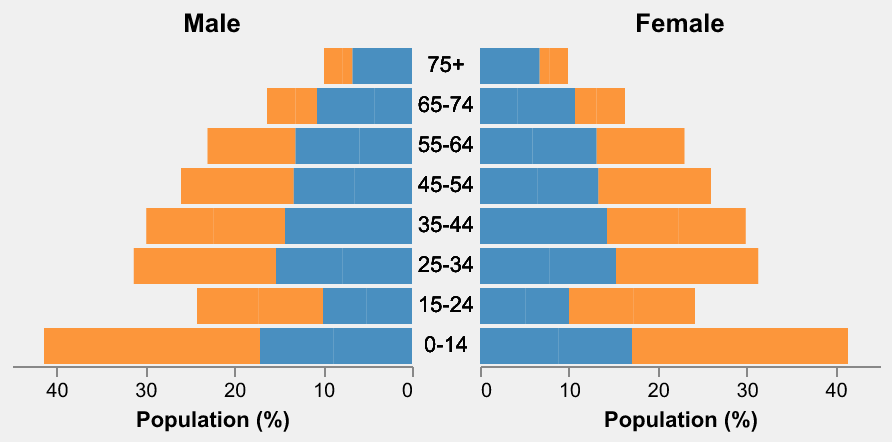What is the age group with the highest male population percentage in Vietnam? To find the age group with the highest male population percentage in Vietnam, look for the largest negative value in the "Vietnam Male" data column. The age group "0-14" has the value -12.5.
Answer: 0-14 Which age group has a larger female population percentage in Russia compared to Vietnam? Compare the percentages of female population for each age group between Russia and Vietnam. In the "55-64" age group, Russia has 7.2% while Vietnam has 5.1%.
Answer: 55-64 What is the total population percentage for the travel-prone age groups (15-64) for both genders in Russia? Sum the male and female population percentages for age groups 15-24, 25-34, 35-44, 45-54, and 55-64 in Russia. The calculation is: (-5.1 + 4.9) + (-7.8 + 7.5) + (-7.2 + 7.1) + (-6.5 + 6.8) + (-5.9 + 7.2) = -5.1 + 4.9 - 7.8 + 7.5 - 7.2 + 7.1 - 6.5 + 6.8 - 5.9 + 7.2 = -32.5% for males and 33.5% for females.
Answer: -32.5% for males, 33.5% for females How does the population percentage of the 25-34 age group in Vietnam compare between genders? Compare the negative value for males and positive value for females in the "25-34" age group in Vietnam. Males have -8.2% and females have 7.8%.
Answer: Males: -8.2%, Females: 7.8% In which age group do both countries have nearly equal male population percentages? Look for the age group where the male percentage values in Vietnam and Russia are close. In the "45-54" age group, both Vietnam and Russia have -6.5%.
Answer: 45-54 What is the average female population percentage for the age groups 35-44 and 45-54 in Vietnam? Add the female population percentages for age groups 35-44 and 45-54 in Vietnam, then divide by 2. The calculation is (7.6 + 6.2) / 2 = 13.8 / 2 = 6.9%.
Answer: 6.9% Which country has a larger population percentage in the 65-74 age group for both genders combined? Sum the male and female population percentages in the 65-74 age group for both Vietnam and Russia. For Vietnam: -2.4 + 3.2 = 0.8%. For Russia: -4.2 + 6.5 = 2.3%. Russia has a higher combined percentage.
Answer: Russia Which age group in Russia has the closest female population percentage to the female population percentage of the 55-64 age group in Vietnam? Compare the female population percentage of the 55-64 age group in Vietnam (5.1%) to all age groups for females in Russia. The 15-24 age group in Russia has 4.9%, which is the closest.
Answer: 15-24 